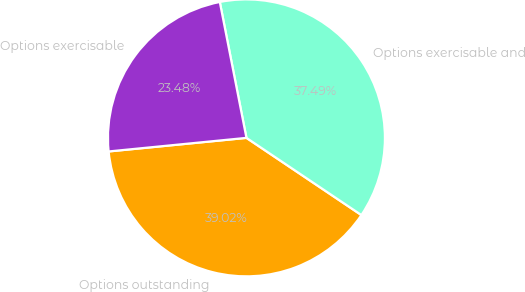<chart> <loc_0><loc_0><loc_500><loc_500><pie_chart><fcel>Options outstanding<fcel>Options exercisable and<fcel>Options exercisable<nl><fcel>39.02%<fcel>37.49%<fcel>23.48%<nl></chart> 